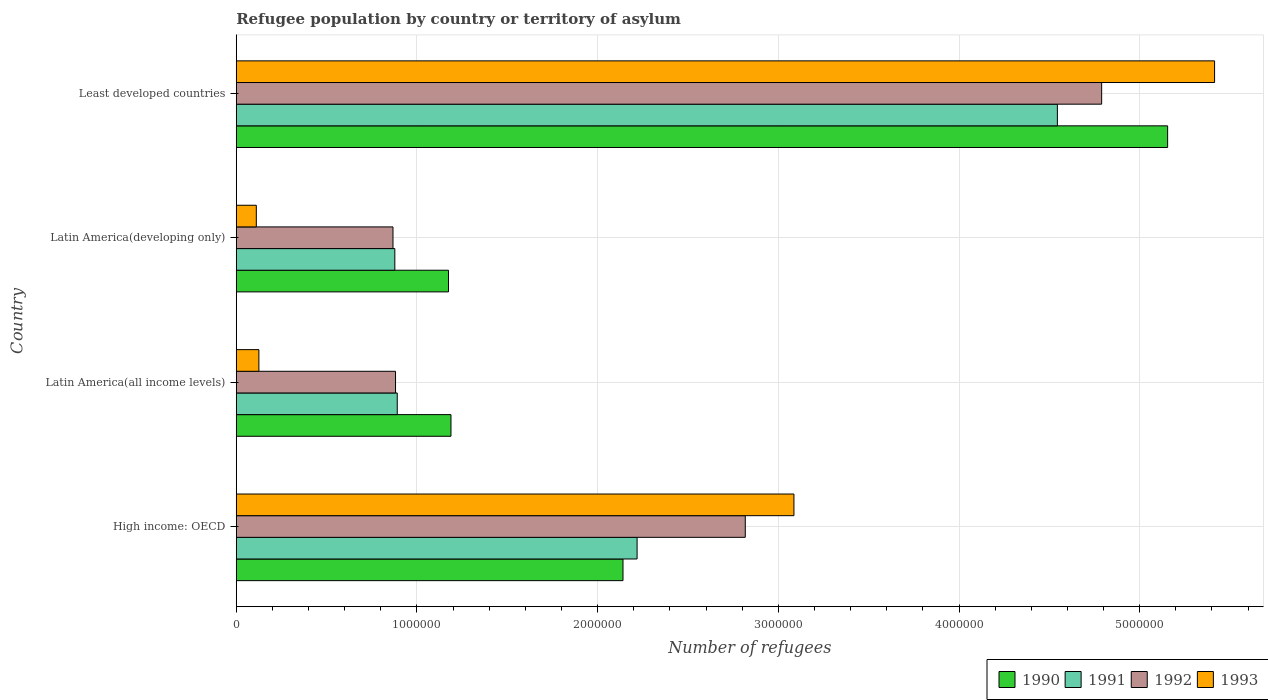How many different coloured bars are there?
Offer a very short reply. 4. Are the number of bars per tick equal to the number of legend labels?
Ensure brevity in your answer.  Yes. Are the number of bars on each tick of the Y-axis equal?
Offer a terse response. Yes. What is the label of the 3rd group of bars from the top?
Your answer should be very brief. Latin America(all income levels). What is the number of refugees in 1993 in Latin America(developing only)?
Your answer should be compact. 1.11e+05. Across all countries, what is the maximum number of refugees in 1993?
Keep it short and to the point. 5.41e+06. Across all countries, what is the minimum number of refugees in 1990?
Offer a very short reply. 1.17e+06. In which country was the number of refugees in 1990 maximum?
Provide a succinct answer. Least developed countries. In which country was the number of refugees in 1991 minimum?
Your response must be concise. Latin America(developing only). What is the total number of refugees in 1992 in the graph?
Your answer should be compact. 9.36e+06. What is the difference between the number of refugees in 1990 in Latin America(all income levels) and that in Least developed countries?
Offer a very short reply. -3.97e+06. What is the difference between the number of refugees in 1991 in Latin America(all income levels) and the number of refugees in 1993 in High income: OECD?
Give a very brief answer. -2.20e+06. What is the average number of refugees in 1991 per country?
Give a very brief answer. 2.13e+06. What is the difference between the number of refugees in 1990 and number of refugees in 1991 in High income: OECD?
Keep it short and to the point. -7.80e+04. What is the ratio of the number of refugees in 1993 in Latin America(all income levels) to that in Least developed countries?
Make the answer very short. 0.02. Is the difference between the number of refugees in 1990 in High income: OECD and Latin America(developing only) greater than the difference between the number of refugees in 1991 in High income: OECD and Latin America(developing only)?
Offer a terse response. No. What is the difference between the highest and the second highest number of refugees in 1990?
Offer a terse response. 3.01e+06. What is the difference between the highest and the lowest number of refugees in 1991?
Offer a terse response. 3.67e+06. Is the sum of the number of refugees in 1993 in Latin America(developing only) and Least developed countries greater than the maximum number of refugees in 1992 across all countries?
Offer a very short reply. Yes. What does the 4th bar from the top in High income: OECD represents?
Provide a succinct answer. 1990. What does the 4th bar from the bottom in Least developed countries represents?
Offer a terse response. 1993. How many bars are there?
Your response must be concise. 16. How many countries are there in the graph?
Give a very brief answer. 4. Does the graph contain any zero values?
Your answer should be very brief. No. Does the graph contain grids?
Make the answer very short. Yes. How many legend labels are there?
Offer a very short reply. 4. What is the title of the graph?
Offer a terse response. Refugee population by country or territory of asylum. What is the label or title of the X-axis?
Provide a short and direct response. Number of refugees. What is the label or title of the Y-axis?
Offer a terse response. Country. What is the Number of refugees of 1990 in High income: OECD?
Ensure brevity in your answer.  2.14e+06. What is the Number of refugees in 1991 in High income: OECD?
Offer a terse response. 2.22e+06. What is the Number of refugees of 1992 in High income: OECD?
Your answer should be very brief. 2.82e+06. What is the Number of refugees of 1993 in High income: OECD?
Your answer should be compact. 3.09e+06. What is the Number of refugees in 1990 in Latin America(all income levels)?
Provide a short and direct response. 1.19e+06. What is the Number of refugees in 1991 in Latin America(all income levels)?
Give a very brief answer. 8.91e+05. What is the Number of refugees in 1992 in Latin America(all income levels)?
Offer a very short reply. 8.82e+05. What is the Number of refugees of 1993 in Latin America(all income levels)?
Your answer should be very brief. 1.25e+05. What is the Number of refugees of 1990 in Latin America(developing only)?
Offer a very short reply. 1.17e+06. What is the Number of refugees in 1991 in Latin America(developing only)?
Offer a terse response. 8.78e+05. What is the Number of refugees in 1992 in Latin America(developing only)?
Offer a very short reply. 8.67e+05. What is the Number of refugees in 1993 in Latin America(developing only)?
Your answer should be compact. 1.11e+05. What is the Number of refugees in 1990 in Least developed countries?
Offer a terse response. 5.15e+06. What is the Number of refugees in 1991 in Least developed countries?
Your answer should be very brief. 4.54e+06. What is the Number of refugees of 1992 in Least developed countries?
Ensure brevity in your answer.  4.79e+06. What is the Number of refugees in 1993 in Least developed countries?
Offer a very short reply. 5.41e+06. Across all countries, what is the maximum Number of refugees in 1990?
Give a very brief answer. 5.15e+06. Across all countries, what is the maximum Number of refugees of 1991?
Provide a short and direct response. 4.54e+06. Across all countries, what is the maximum Number of refugees of 1992?
Your answer should be very brief. 4.79e+06. Across all countries, what is the maximum Number of refugees in 1993?
Make the answer very short. 5.41e+06. Across all countries, what is the minimum Number of refugees in 1990?
Provide a short and direct response. 1.17e+06. Across all countries, what is the minimum Number of refugees in 1991?
Give a very brief answer. 8.78e+05. Across all countries, what is the minimum Number of refugees of 1992?
Your answer should be compact. 8.67e+05. Across all countries, what is the minimum Number of refugees in 1993?
Make the answer very short. 1.11e+05. What is the total Number of refugees of 1990 in the graph?
Ensure brevity in your answer.  9.66e+06. What is the total Number of refugees in 1991 in the graph?
Your response must be concise. 8.53e+06. What is the total Number of refugees in 1992 in the graph?
Your answer should be very brief. 9.36e+06. What is the total Number of refugees of 1993 in the graph?
Keep it short and to the point. 8.74e+06. What is the difference between the Number of refugees in 1990 in High income: OECD and that in Latin America(all income levels)?
Offer a very short reply. 9.52e+05. What is the difference between the Number of refugees of 1991 in High income: OECD and that in Latin America(all income levels)?
Offer a terse response. 1.33e+06. What is the difference between the Number of refugees of 1992 in High income: OECD and that in Latin America(all income levels)?
Give a very brief answer. 1.94e+06. What is the difference between the Number of refugees of 1993 in High income: OECD and that in Latin America(all income levels)?
Your answer should be compact. 2.96e+06. What is the difference between the Number of refugees of 1990 in High income: OECD and that in Latin America(developing only)?
Ensure brevity in your answer.  9.66e+05. What is the difference between the Number of refugees in 1991 in High income: OECD and that in Latin America(developing only)?
Provide a short and direct response. 1.34e+06. What is the difference between the Number of refugees in 1992 in High income: OECD and that in Latin America(developing only)?
Ensure brevity in your answer.  1.95e+06. What is the difference between the Number of refugees in 1993 in High income: OECD and that in Latin America(developing only)?
Your response must be concise. 2.98e+06. What is the difference between the Number of refugees of 1990 in High income: OECD and that in Least developed countries?
Your answer should be very brief. -3.01e+06. What is the difference between the Number of refugees of 1991 in High income: OECD and that in Least developed countries?
Provide a short and direct response. -2.33e+06. What is the difference between the Number of refugees of 1992 in High income: OECD and that in Least developed countries?
Make the answer very short. -1.97e+06. What is the difference between the Number of refugees in 1993 in High income: OECD and that in Least developed countries?
Provide a succinct answer. -2.33e+06. What is the difference between the Number of refugees of 1990 in Latin America(all income levels) and that in Latin America(developing only)?
Keep it short and to the point. 1.36e+04. What is the difference between the Number of refugees of 1991 in Latin America(all income levels) and that in Latin America(developing only)?
Give a very brief answer. 1.34e+04. What is the difference between the Number of refugees in 1992 in Latin America(all income levels) and that in Latin America(developing only)?
Offer a terse response. 1.41e+04. What is the difference between the Number of refugees of 1993 in Latin America(all income levels) and that in Latin America(developing only)?
Make the answer very short. 1.43e+04. What is the difference between the Number of refugees in 1990 in Latin America(all income levels) and that in Least developed countries?
Your answer should be compact. -3.97e+06. What is the difference between the Number of refugees of 1991 in Latin America(all income levels) and that in Least developed countries?
Your answer should be compact. -3.65e+06. What is the difference between the Number of refugees of 1992 in Latin America(all income levels) and that in Least developed countries?
Your answer should be very brief. -3.91e+06. What is the difference between the Number of refugees in 1993 in Latin America(all income levels) and that in Least developed countries?
Offer a terse response. -5.29e+06. What is the difference between the Number of refugees of 1990 in Latin America(developing only) and that in Least developed countries?
Your answer should be compact. -3.98e+06. What is the difference between the Number of refugees of 1991 in Latin America(developing only) and that in Least developed countries?
Provide a short and direct response. -3.67e+06. What is the difference between the Number of refugees in 1992 in Latin America(developing only) and that in Least developed countries?
Offer a very short reply. -3.92e+06. What is the difference between the Number of refugees of 1993 in Latin America(developing only) and that in Least developed countries?
Provide a short and direct response. -5.30e+06. What is the difference between the Number of refugees of 1990 in High income: OECD and the Number of refugees of 1991 in Latin America(all income levels)?
Offer a very short reply. 1.25e+06. What is the difference between the Number of refugees in 1990 in High income: OECD and the Number of refugees in 1992 in Latin America(all income levels)?
Your answer should be compact. 1.26e+06. What is the difference between the Number of refugees in 1990 in High income: OECD and the Number of refugees in 1993 in Latin America(all income levels)?
Your answer should be very brief. 2.02e+06. What is the difference between the Number of refugees of 1991 in High income: OECD and the Number of refugees of 1992 in Latin America(all income levels)?
Provide a short and direct response. 1.34e+06. What is the difference between the Number of refugees of 1991 in High income: OECD and the Number of refugees of 1993 in Latin America(all income levels)?
Provide a short and direct response. 2.09e+06. What is the difference between the Number of refugees in 1992 in High income: OECD and the Number of refugees in 1993 in Latin America(all income levels)?
Give a very brief answer. 2.69e+06. What is the difference between the Number of refugees of 1990 in High income: OECD and the Number of refugees of 1991 in Latin America(developing only)?
Ensure brevity in your answer.  1.26e+06. What is the difference between the Number of refugees in 1990 in High income: OECD and the Number of refugees in 1992 in Latin America(developing only)?
Offer a terse response. 1.27e+06. What is the difference between the Number of refugees in 1990 in High income: OECD and the Number of refugees in 1993 in Latin America(developing only)?
Keep it short and to the point. 2.03e+06. What is the difference between the Number of refugees of 1991 in High income: OECD and the Number of refugees of 1992 in Latin America(developing only)?
Give a very brief answer. 1.35e+06. What is the difference between the Number of refugees in 1991 in High income: OECD and the Number of refugees in 1993 in Latin America(developing only)?
Offer a terse response. 2.11e+06. What is the difference between the Number of refugees in 1992 in High income: OECD and the Number of refugees in 1993 in Latin America(developing only)?
Give a very brief answer. 2.71e+06. What is the difference between the Number of refugees in 1990 in High income: OECD and the Number of refugees in 1991 in Least developed countries?
Keep it short and to the point. -2.40e+06. What is the difference between the Number of refugees of 1990 in High income: OECD and the Number of refugees of 1992 in Least developed countries?
Provide a short and direct response. -2.65e+06. What is the difference between the Number of refugees in 1990 in High income: OECD and the Number of refugees in 1993 in Least developed countries?
Provide a short and direct response. -3.27e+06. What is the difference between the Number of refugees in 1991 in High income: OECD and the Number of refugees in 1992 in Least developed countries?
Keep it short and to the point. -2.57e+06. What is the difference between the Number of refugees of 1991 in High income: OECD and the Number of refugees of 1993 in Least developed countries?
Ensure brevity in your answer.  -3.20e+06. What is the difference between the Number of refugees of 1992 in High income: OECD and the Number of refugees of 1993 in Least developed countries?
Make the answer very short. -2.60e+06. What is the difference between the Number of refugees of 1990 in Latin America(all income levels) and the Number of refugees of 1991 in Latin America(developing only)?
Ensure brevity in your answer.  3.11e+05. What is the difference between the Number of refugees of 1990 in Latin America(all income levels) and the Number of refugees of 1992 in Latin America(developing only)?
Make the answer very short. 3.21e+05. What is the difference between the Number of refugees of 1990 in Latin America(all income levels) and the Number of refugees of 1993 in Latin America(developing only)?
Ensure brevity in your answer.  1.08e+06. What is the difference between the Number of refugees in 1991 in Latin America(all income levels) and the Number of refugees in 1992 in Latin America(developing only)?
Offer a terse response. 2.35e+04. What is the difference between the Number of refugees of 1991 in Latin America(all income levels) and the Number of refugees of 1993 in Latin America(developing only)?
Provide a succinct answer. 7.80e+05. What is the difference between the Number of refugees in 1992 in Latin America(all income levels) and the Number of refugees in 1993 in Latin America(developing only)?
Make the answer very short. 7.71e+05. What is the difference between the Number of refugees in 1990 in Latin America(all income levels) and the Number of refugees in 1991 in Least developed countries?
Provide a succinct answer. -3.36e+06. What is the difference between the Number of refugees in 1990 in Latin America(all income levels) and the Number of refugees in 1992 in Least developed countries?
Provide a succinct answer. -3.60e+06. What is the difference between the Number of refugees in 1990 in Latin America(all income levels) and the Number of refugees in 1993 in Least developed countries?
Keep it short and to the point. -4.23e+06. What is the difference between the Number of refugees of 1991 in Latin America(all income levels) and the Number of refugees of 1992 in Least developed countries?
Give a very brief answer. -3.90e+06. What is the difference between the Number of refugees in 1991 in Latin America(all income levels) and the Number of refugees in 1993 in Least developed countries?
Provide a succinct answer. -4.52e+06. What is the difference between the Number of refugees of 1992 in Latin America(all income levels) and the Number of refugees of 1993 in Least developed countries?
Provide a short and direct response. -4.53e+06. What is the difference between the Number of refugees in 1990 in Latin America(developing only) and the Number of refugees in 1991 in Least developed countries?
Your answer should be very brief. -3.37e+06. What is the difference between the Number of refugees in 1990 in Latin America(developing only) and the Number of refugees in 1992 in Least developed countries?
Give a very brief answer. -3.61e+06. What is the difference between the Number of refugees in 1990 in Latin America(developing only) and the Number of refugees in 1993 in Least developed countries?
Give a very brief answer. -4.24e+06. What is the difference between the Number of refugees in 1991 in Latin America(developing only) and the Number of refugees in 1992 in Least developed countries?
Ensure brevity in your answer.  -3.91e+06. What is the difference between the Number of refugees of 1991 in Latin America(developing only) and the Number of refugees of 1993 in Least developed countries?
Offer a very short reply. -4.54e+06. What is the difference between the Number of refugees in 1992 in Latin America(developing only) and the Number of refugees in 1993 in Least developed countries?
Make the answer very short. -4.55e+06. What is the average Number of refugees of 1990 per country?
Ensure brevity in your answer.  2.41e+06. What is the average Number of refugees in 1991 per country?
Give a very brief answer. 2.13e+06. What is the average Number of refugees of 1992 per country?
Ensure brevity in your answer.  2.34e+06. What is the average Number of refugees in 1993 per country?
Give a very brief answer. 2.18e+06. What is the difference between the Number of refugees in 1990 and Number of refugees in 1991 in High income: OECD?
Your answer should be compact. -7.80e+04. What is the difference between the Number of refugees of 1990 and Number of refugees of 1992 in High income: OECD?
Provide a short and direct response. -6.77e+05. What is the difference between the Number of refugees in 1990 and Number of refugees in 1993 in High income: OECD?
Ensure brevity in your answer.  -9.46e+05. What is the difference between the Number of refugees of 1991 and Number of refugees of 1992 in High income: OECD?
Your answer should be very brief. -5.99e+05. What is the difference between the Number of refugees of 1991 and Number of refugees of 1993 in High income: OECD?
Your response must be concise. -8.68e+05. What is the difference between the Number of refugees in 1992 and Number of refugees in 1993 in High income: OECD?
Your answer should be very brief. -2.69e+05. What is the difference between the Number of refugees of 1990 and Number of refugees of 1991 in Latin America(all income levels)?
Your response must be concise. 2.97e+05. What is the difference between the Number of refugees in 1990 and Number of refugees in 1992 in Latin America(all income levels)?
Ensure brevity in your answer.  3.07e+05. What is the difference between the Number of refugees in 1990 and Number of refugees in 1993 in Latin America(all income levels)?
Ensure brevity in your answer.  1.06e+06. What is the difference between the Number of refugees in 1991 and Number of refugees in 1992 in Latin America(all income levels)?
Your answer should be very brief. 9437. What is the difference between the Number of refugees in 1991 and Number of refugees in 1993 in Latin America(all income levels)?
Give a very brief answer. 7.66e+05. What is the difference between the Number of refugees of 1992 and Number of refugees of 1993 in Latin America(all income levels)?
Make the answer very short. 7.56e+05. What is the difference between the Number of refugees of 1990 and Number of refugees of 1991 in Latin America(developing only)?
Offer a very short reply. 2.97e+05. What is the difference between the Number of refugees of 1990 and Number of refugees of 1992 in Latin America(developing only)?
Provide a succinct answer. 3.07e+05. What is the difference between the Number of refugees of 1990 and Number of refugees of 1993 in Latin America(developing only)?
Offer a terse response. 1.06e+06. What is the difference between the Number of refugees in 1991 and Number of refugees in 1992 in Latin America(developing only)?
Give a very brief answer. 1.01e+04. What is the difference between the Number of refugees of 1991 and Number of refugees of 1993 in Latin America(developing only)?
Keep it short and to the point. 7.67e+05. What is the difference between the Number of refugees in 1992 and Number of refugees in 1993 in Latin America(developing only)?
Your answer should be very brief. 7.56e+05. What is the difference between the Number of refugees of 1990 and Number of refugees of 1991 in Least developed countries?
Ensure brevity in your answer.  6.10e+05. What is the difference between the Number of refugees of 1990 and Number of refugees of 1992 in Least developed countries?
Ensure brevity in your answer.  3.65e+05. What is the difference between the Number of refugees in 1990 and Number of refugees in 1993 in Least developed countries?
Your answer should be compact. -2.60e+05. What is the difference between the Number of refugees of 1991 and Number of refugees of 1992 in Least developed countries?
Keep it short and to the point. -2.45e+05. What is the difference between the Number of refugees of 1991 and Number of refugees of 1993 in Least developed countries?
Give a very brief answer. -8.70e+05. What is the difference between the Number of refugees in 1992 and Number of refugees in 1993 in Least developed countries?
Provide a short and direct response. -6.25e+05. What is the ratio of the Number of refugees of 1990 in High income: OECD to that in Latin America(all income levels)?
Give a very brief answer. 1.8. What is the ratio of the Number of refugees of 1991 in High income: OECD to that in Latin America(all income levels)?
Keep it short and to the point. 2.49. What is the ratio of the Number of refugees in 1992 in High income: OECD to that in Latin America(all income levels)?
Offer a terse response. 3.2. What is the ratio of the Number of refugees in 1993 in High income: OECD to that in Latin America(all income levels)?
Your answer should be very brief. 24.64. What is the ratio of the Number of refugees of 1990 in High income: OECD to that in Latin America(developing only)?
Make the answer very short. 1.82. What is the ratio of the Number of refugees of 1991 in High income: OECD to that in Latin America(developing only)?
Offer a very short reply. 2.53. What is the ratio of the Number of refugees in 1992 in High income: OECD to that in Latin America(developing only)?
Provide a succinct answer. 3.25. What is the ratio of the Number of refugees of 1993 in High income: OECD to that in Latin America(developing only)?
Give a very brief answer. 27.81. What is the ratio of the Number of refugees of 1990 in High income: OECD to that in Least developed countries?
Your answer should be compact. 0.42. What is the ratio of the Number of refugees in 1991 in High income: OECD to that in Least developed countries?
Give a very brief answer. 0.49. What is the ratio of the Number of refugees of 1992 in High income: OECD to that in Least developed countries?
Make the answer very short. 0.59. What is the ratio of the Number of refugees in 1993 in High income: OECD to that in Least developed countries?
Your answer should be compact. 0.57. What is the ratio of the Number of refugees of 1990 in Latin America(all income levels) to that in Latin America(developing only)?
Your response must be concise. 1.01. What is the ratio of the Number of refugees of 1991 in Latin America(all income levels) to that in Latin America(developing only)?
Offer a very short reply. 1.02. What is the ratio of the Number of refugees in 1992 in Latin America(all income levels) to that in Latin America(developing only)?
Your answer should be very brief. 1.02. What is the ratio of the Number of refugees in 1993 in Latin America(all income levels) to that in Latin America(developing only)?
Your answer should be compact. 1.13. What is the ratio of the Number of refugees of 1990 in Latin America(all income levels) to that in Least developed countries?
Offer a terse response. 0.23. What is the ratio of the Number of refugees of 1991 in Latin America(all income levels) to that in Least developed countries?
Provide a short and direct response. 0.2. What is the ratio of the Number of refugees of 1992 in Latin America(all income levels) to that in Least developed countries?
Provide a succinct answer. 0.18. What is the ratio of the Number of refugees in 1993 in Latin America(all income levels) to that in Least developed countries?
Provide a succinct answer. 0.02. What is the ratio of the Number of refugees of 1990 in Latin America(developing only) to that in Least developed countries?
Offer a very short reply. 0.23. What is the ratio of the Number of refugees in 1991 in Latin America(developing only) to that in Least developed countries?
Your response must be concise. 0.19. What is the ratio of the Number of refugees of 1992 in Latin America(developing only) to that in Least developed countries?
Provide a short and direct response. 0.18. What is the ratio of the Number of refugees of 1993 in Latin America(developing only) to that in Least developed countries?
Ensure brevity in your answer.  0.02. What is the difference between the highest and the second highest Number of refugees in 1990?
Give a very brief answer. 3.01e+06. What is the difference between the highest and the second highest Number of refugees in 1991?
Provide a succinct answer. 2.33e+06. What is the difference between the highest and the second highest Number of refugees of 1992?
Your answer should be compact. 1.97e+06. What is the difference between the highest and the second highest Number of refugees in 1993?
Provide a short and direct response. 2.33e+06. What is the difference between the highest and the lowest Number of refugees of 1990?
Give a very brief answer. 3.98e+06. What is the difference between the highest and the lowest Number of refugees of 1991?
Your answer should be compact. 3.67e+06. What is the difference between the highest and the lowest Number of refugees in 1992?
Offer a terse response. 3.92e+06. What is the difference between the highest and the lowest Number of refugees of 1993?
Ensure brevity in your answer.  5.30e+06. 